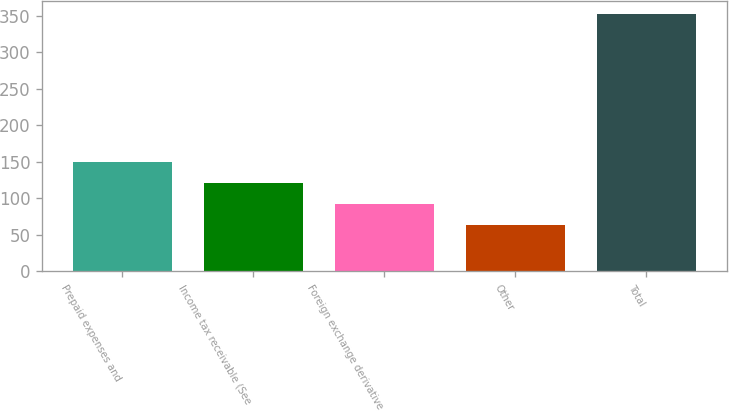<chart> <loc_0><loc_0><loc_500><loc_500><bar_chart><fcel>Prepaid expenses and<fcel>Income tax receivable (See<fcel>Foreign exchange derivative<fcel>Other<fcel>Total<nl><fcel>150<fcel>121<fcel>92<fcel>63<fcel>353<nl></chart> 